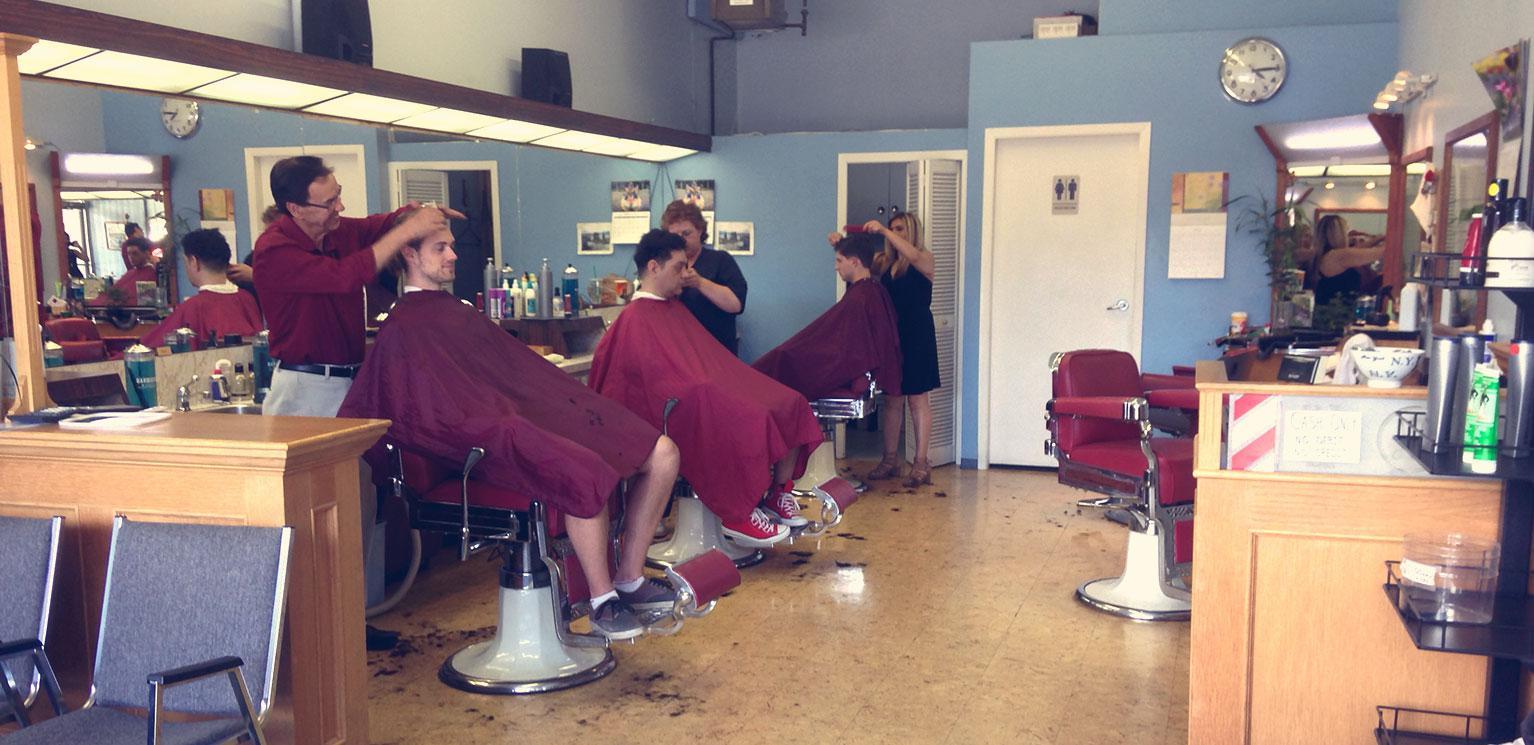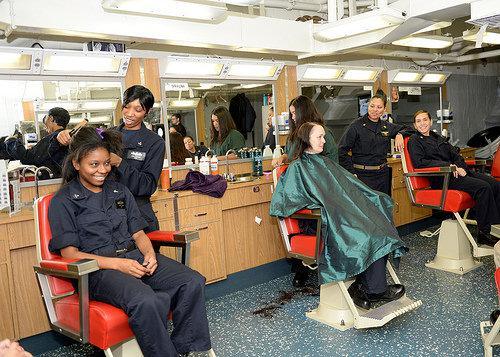The first image is the image on the left, the second image is the image on the right. For the images displayed, is the sentence "At least one of the images has someone getting their hair cut with a purple apron over their laps." factually correct? Answer yes or no. Yes. The first image is the image on the left, the second image is the image on the right. Examine the images to the left and right. Is the description "An image shows salon customers wearing purple protective capes." accurate? Answer yes or no. Yes. 